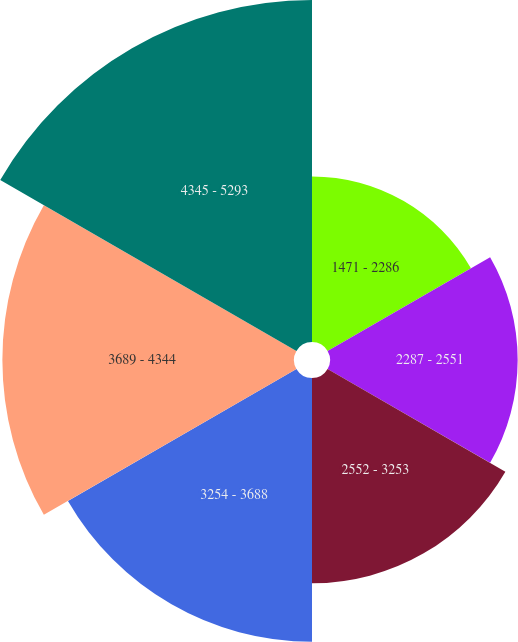Convert chart to OTSL. <chart><loc_0><loc_0><loc_500><loc_500><pie_chart><fcel>1471 - 2286<fcel>2287 - 2551<fcel>2552 - 3253<fcel>3254 - 3688<fcel>3689 - 4344<fcel>4345 - 5293<nl><fcel>11.37%<fcel>12.89%<fcel>14.1%<fcel>18.12%<fcel>20.03%<fcel>23.49%<nl></chart> 